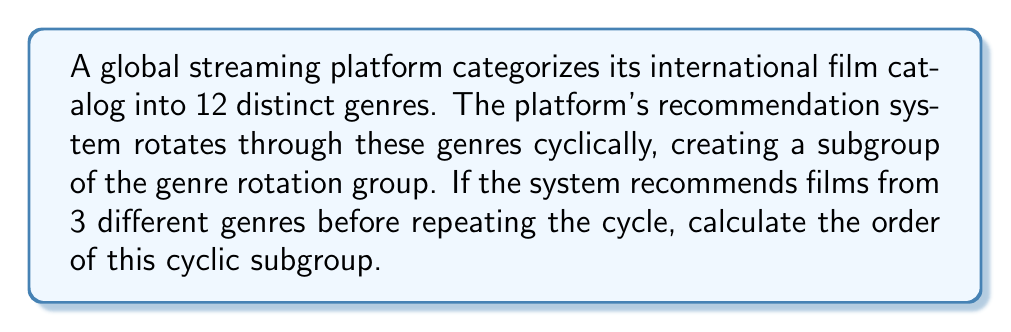Can you solve this math problem? To solve this problem, we need to understand the concept of cyclic subgroups and how they relate to the given scenario:

1) The full group of genres can be represented as $G = \{1, 2, 3, ..., 12\}$, where each number represents a distinct genre. This group has order 12.

2) The recommendation system creates a cyclic subgroup by rotating through only 3 genres before repeating. Let's call this subgroup $H$.

3) In group theory, the order of an element $a$ in a group is the smallest positive integer $n$ such that $a^n = e$ (the identity element).

4) In this case, we're looking for the smallest number of rotations that will bring us back to our starting point. This is equivalent to finding the least common multiple (LCM) of the total number of genres (12) and the number of genres in each cycle (3).

5) We can calculate this as follows:

   $\text{LCM}(12,3) = \frac{12 \times 3}{\text{GCD}(12,3)}$

   Where GCD is the Greatest Common Divisor.

6) $\text{GCD}(12,3) = 3$

7) Therefore:

   $\text{LCM}(12,3) = \frac{12 \times 3}{3} = 12$

8) This means that after 12 recommendations, the system will have completed 4 full cycles and return to its starting point.

9) Thus, the order of the cyclic subgroup $H$ is 12.
Answer: The order of the cyclic subgroup is 12. 